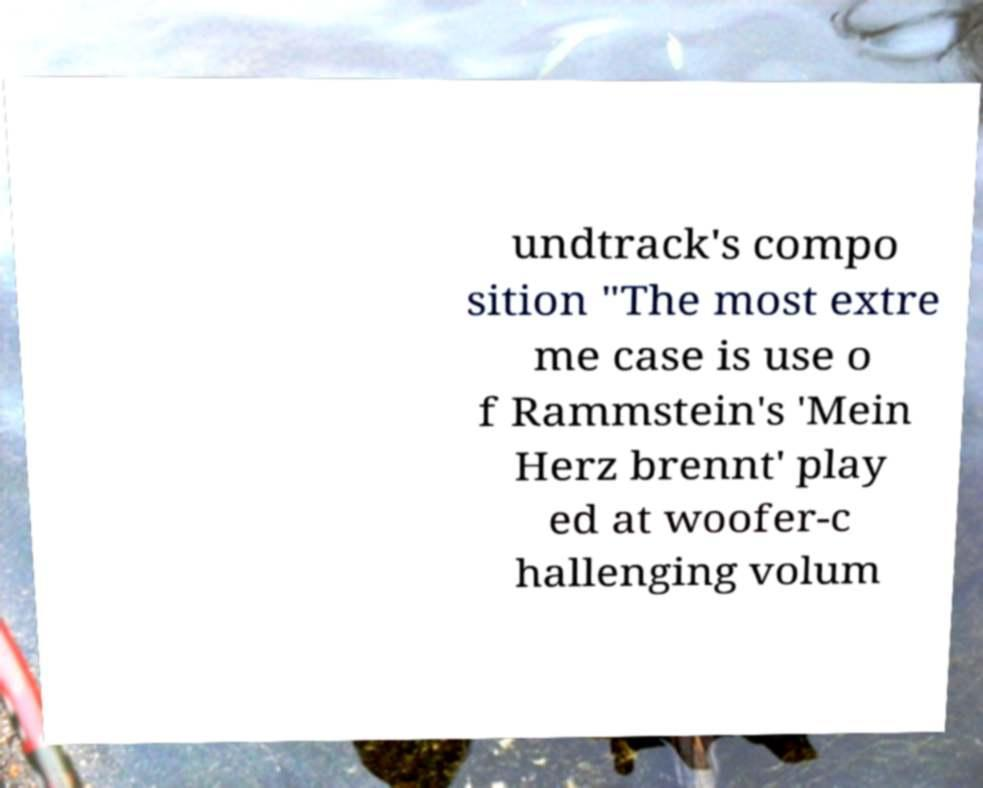Could you assist in decoding the text presented in this image and type it out clearly? undtrack's compo sition "The most extre me case is use o f Rammstein's 'Mein Herz brennt' play ed at woofer-c hallenging volum 